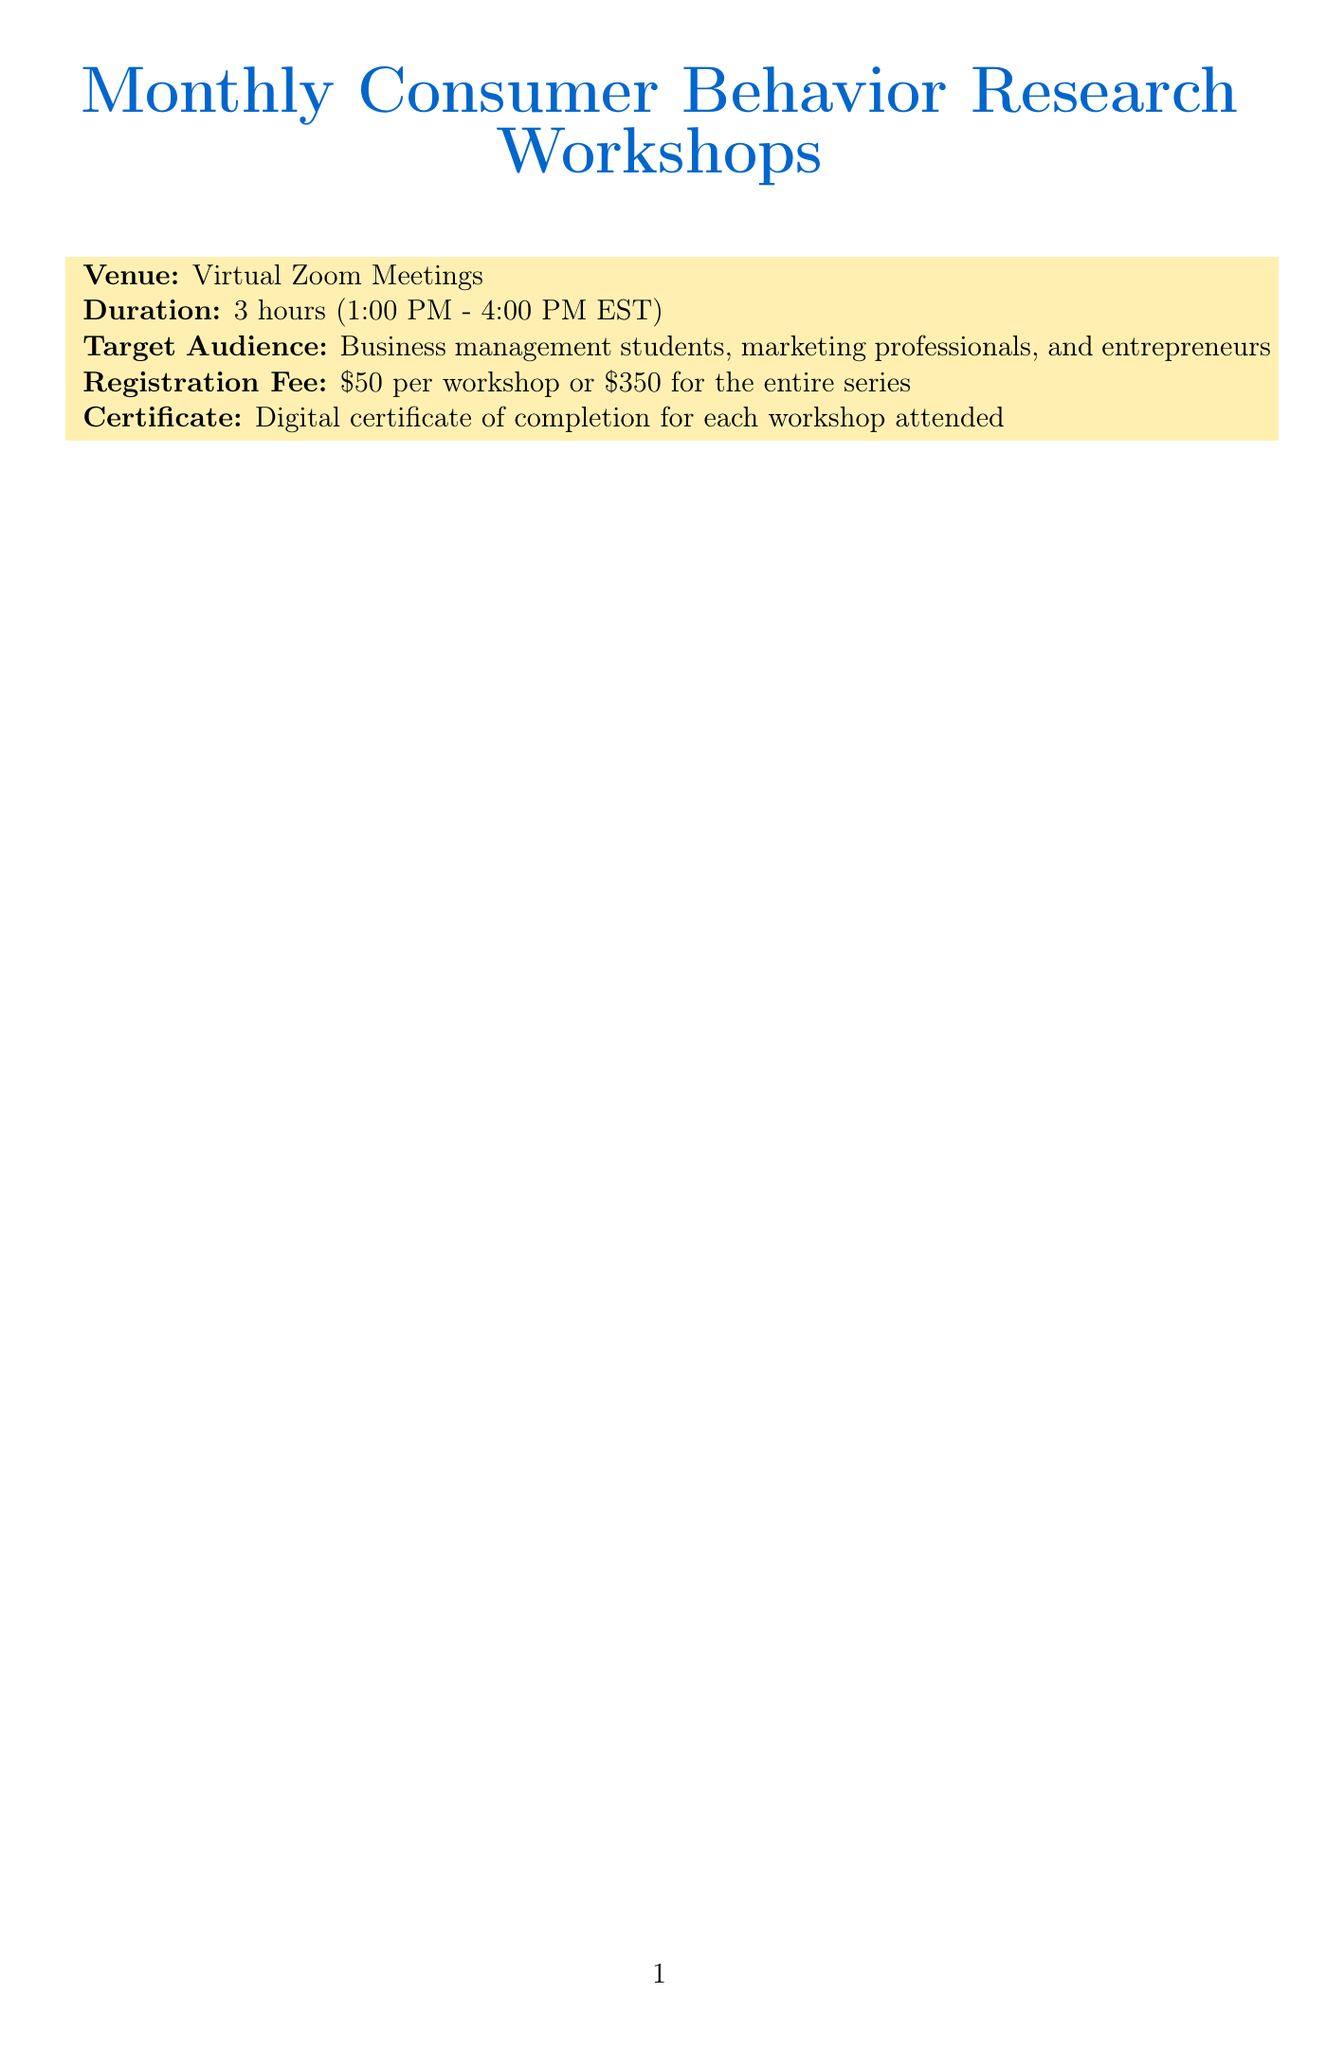what is the title of the first workshop? The title of the first workshop listed is "Understanding Gen Z Consumer Preferences."
Answer: Understanding Gen Z Consumer Preferences who is the speaker for the workshop on sustainable consumption? The speaker for the sustainable consumption workshop is Mark Johnson, Chief Sustainability Officer at Unilever.
Answer: Mark Johnson what case study is associated with the workshop on impulse buying? The case study associated with the workshop on impulse buying is "Amazon's One-Click Purchase Feature: Streamlining the Buying Process."
Answer: Amazon's One-Click Purchase Feature: Streamlining the Buying Process when is the workshop on the role of artificial intelligence scheduled? The workshop on the role of artificial intelligence is scheduled for September 1, 2023.
Answer: September 1, 2023 how long does each workshop last? Each workshop lasts for 3 hours from 1:00 PM to 4:00 PM EST.
Answer: 3 hours what is the registration fee for attending all workshops? The registration fee for attending all workshops in the series is $350.
Answer: $350 which workshop features a case study on influencer marketing? The workshop featuring a case study on influencer marketing is titled "Influencer Marketing: Measuring ROI and Authenticity."
Answer: Influencer Marketing: Measuring ROI and Authenticity who is the target audience for these workshops? The target audience for these workshops includes business management students, marketing professionals, and entrepreneurs.
Answer: Business management students, marketing professionals, and entrepreneurs 